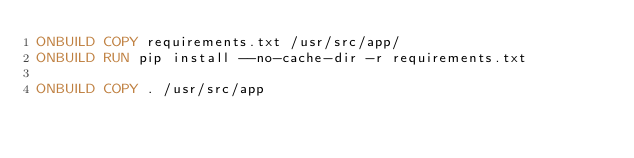<code> <loc_0><loc_0><loc_500><loc_500><_Dockerfile_>ONBUILD COPY requirements.txt /usr/src/app/
ONBUILD RUN pip install --no-cache-dir -r requirements.txt

ONBUILD COPY . /usr/src/app
</code> 